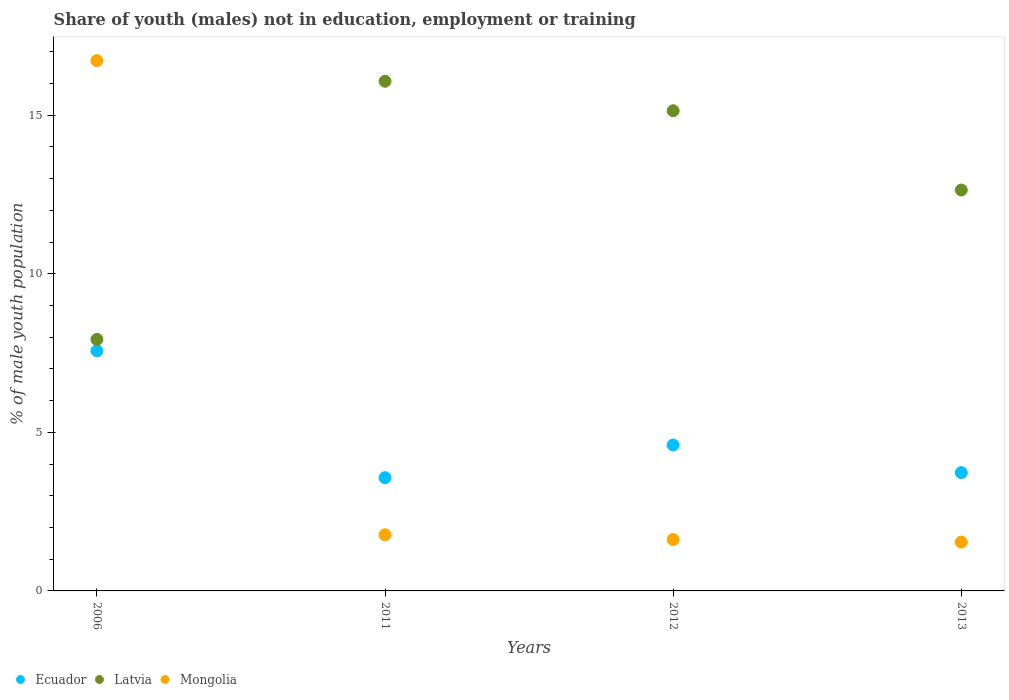Is the number of dotlines equal to the number of legend labels?
Give a very brief answer. Yes. What is the percentage of unemployed males population in in Ecuador in 2006?
Give a very brief answer. 7.57. Across all years, what is the maximum percentage of unemployed males population in in Ecuador?
Give a very brief answer. 7.57. Across all years, what is the minimum percentage of unemployed males population in in Ecuador?
Provide a short and direct response. 3.57. What is the total percentage of unemployed males population in in Ecuador in the graph?
Ensure brevity in your answer.  19.47. What is the difference between the percentage of unemployed males population in in Mongolia in 2011 and that in 2012?
Ensure brevity in your answer.  0.15. What is the difference between the percentage of unemployed males population in in Latvia in 2013 and the percentage of unemployed males population in in Ecuador in 2012?
Provide a short and direct response. 8.04. What is the average percentage of unemployed males population in in Mongolia per year?
Your answer should be very brief. 5.41. In the year 2006, what is the difference between the percentage of unemployed males population in in Mongolia and percentage of unemployed males population in in Ecuador?
Offer a terse response. 9.15. In how many years, is the percentage of unemployed males population in in Ecuador greater than 9 %?
Make the answer very short. 0. What is the ratio of the percentage of unemployed males population in in Mongolia in 2011 to that in 2012?
Keep it short and to the point. 1.09. What is the difference between the highest and the second highest percentage of unemployed males population in in Ecuador?
Provide a short and direct response. 2.97. What is the difference between the highest and the lowest percentage of unemployed males population in in Ecuador?
Keep it short and to the point. 4. Is the sum of the percentage of unemployed males population in in Ecuador in 2011 and 2013 greater than the maximum percentage of unemployed males population in in Latvia across all years?
Make the answer very short. No. Is it the case that in every year, the sum of the percentage of unemployed males population in in Latvia and percentage of unemployed males population in in Ecuador  is greater than the percentage of unemployed males population in in Mongolia?
Offer a terse response. No. Does the percentage of unemployed males population in in Ecuador monotonically increase over the years?
Make the answer very short. No. How many dotlines are there?
Offer a very short reply. 3. Are the values on the major ticks of Y-axis written in scientific E-notation?
Give a very brief answer. No. Does the graph contain any zero values?
Offer a very short reply. No. How many legend labels are there?
Your response must be concise. 3. What is the title of the graph?
Make the answer very short. Share of youth (males) not in education, employment or training. What is the label or title of the Y-axis?
Provide a short and direct response. % of male youth population. What is the % of male youth population of Ecuador in 2006?
Give a very brief answer. 7.57. What is the % of male youth population of Latvia in 2006?
Provide a short and direct response. 7.93. What is the % of male youth population of Mongolia in 2006?
Your answer should be very brief. 16.72. What is the % of male youth population of Ecuador in 2011?
Offer a very short reply. 3.57. What is the % of male youth population in Latvia in 2011?
Keep it short and to the point. 16.07. What is the % of male youth population in Mongolia in 2011?
Give a very brief answer. 1.77. What is the % of male youth population in Ecuador in 2012?
Provide a succinct answer. 4.6. What is the % of male youth population of Latvia in 2012?
Your response must be concise. 15.14. What is the % of male youth population in Mongolia in 2012?
Offer a terse response. 1.62. What is the % of male youth population in Ecuador in 2013?
Make the answer very short. 3.73. What is the % of male youth population in Latvia in 2013?
Make the answer very short. 12.64. What is the % of male youth population of Mongolia in 2013?
Make the answer very short. 1.54. Across all years, what is the maximum % of male youth population in Ecuador?
Make the answer very short. 7.57. Across all years, what is the maximum % of male youth population in Latvia?
Your answer should be very brief. 16.07. Across all years, what is the maximum % of male youth population in Mongolia?
Offer a terse response. 16.72. Across all years, what is the minimum % of male youth population in Ecuador?
Your answer should be compact. 3.57. Across all years, what is the minimum % of male youth population in Latvia?
Offer a very short reply. 7.93. Across all years, what is the minimum % of male youth population of Mongolia?
Provide a succinct answer. 1.54. What is the total % of male youth population of Ecuador in the graph?
Make the answer very short. 19.47. What is the total % of male youth population in Latvia in the graph?
Keep it short and to the point. 51.78. What is the total % of male youth population of Mongolia in the graph?
Provide a succinct answer. 21.65. What is the difference between the % of male youth population in Latvia in 2006 and that in 2011?
Provide a short and direct response. -8.14. What is the difference between the % of male youth population of Mongolia in 2006 and that in 2011?
Your response must be concise. 14.95. What is the difference between the % of male youth population in Ecuador in 2006 and that in 2012?
Offer a terse response. 2.97. What is the difference between the % of male youth population of Latvia in 2006 and that in 2012?
Give a very brief answer. -7.21. What is the difference between the % of male youth population of Mongolia in 2006 and that in 2012?
Provide a succinct answer. 15.1. What is the difference between the % of male youth population in Ecuador in 2006 and that in 2013?
Make the answer very short. 3.84. What is the difference between the % of male youth population of Latvia in 2006 and that in 2013?
Your response must be concise. -4.71. What is the difference between the % of male youth population in Mongolia in 2006 and that in 2013?
Your answer should be compact. 15.18. What is the difference between the % of male youth population in Ecuador in 2011 and that in 2012?
Make the answer very short. -1.03. What is the difference between the % of male youth population in Latvia in 2011 and that in 2012?
Keep it short and to the point. 0.93. What is the difference between the % of male youth population of Ecuador in 2011 and that in 2013?
Your answer should be very brief. -0.16. What is the difference between the % of male youth population in Latvia in 2011 and that in 2013?
Offer a very short reply. 3.43. What is the difference between the % of male youth population in Mongolia in 2011 and that in 2013?
Give a very brief answer. 0.23. What is the difference between the % of male youth population in Ecuador in 2012 and that in 2013?
Keep it short and to the point. 0.87. What is the difference between the % of male youth population of Latvia in 2012 and that in 2013?
Provide a short and direct response. 2.5. What is the difference between the % of male youth population of Ecuador in 2006 and the % of male youth population of Mongolia in 2011?
Give a very brief answer. 5.8. What is the difference between the % of male youth population in Latvia in 2006 and the % of male youth population in Mongolia in 2011?
Your response must be concise. 6.16. What is the difference between the % of male youth population of Ecuador in 2006 and the % of male youth population of Latvia in 2012?
Provide a succinct answer. -7.57. What is the difference between the % of male youth population in Ecuador in 2006 and the % of male youth population in Mongolia in 2012?
Give a very brief answer. 5.95. What is the difference between the % of male youth population in Latvia in 2006 and the % of male youth population in Mongolia in 2012?
Your answer should be compact. 6.31. What is the difference between the % of male youth population in Ecuador in 2006 and the % of male youth population in Latvia in 2013?
Make the answer very short. -5.07. What is the difference between the % of male youth population of Ecuador in 2006 and the % of male youth population of Mongolia in 2013?
Give a very brief answer. 6.03. What is the difference between the % of male youth population of Latvia in 2006 and the % of male youth population of Mongolia in 2013?
Your answer should be compact. 6.39. What is the difference between the % of male youth population of Ecuador in 2011 and the % of male youth population of Latvia in 2012?
Provide a succinct answer. -11.57. What is the difference between the % of male youth population of Ecuador in 2011 and the % of male youth population of Mongolia in 2012?
Provide a succinct answer. 1.95. What is the difference between the % of male youth population in Latvia in 2011 and the % of male youth population in Mongolia in 2012?
Make the answer very short. 14.45. What is the difference between the % of male youth population of Ecuador in 2011 and the % of male youth population of Latvia in 2013?
Provide a short and direct response. -9.07. What is the difference between the % of male youth population of Ecuador in 2011 and the % of male youth population of Mongolia in 2013?
Your answer should be very brief. 2.03. What is the difference between the % of male youth population in Latvia in 2011 and the % of male youth population in Mongolia in 2013?
Provide a short and direct response. 14.53. What is the difference between the % of male youth population in Ecuador in 2012 and the % of male youth population in Latvia in 2013?
Ensure brevity in your answer.  -8.04. What is the difference between the % of male youth population in Ecuador in 2012 and the % of male youth population in Mongolia in 2013?
Provide a short and direct response. 3.06. What is the difference between the % of male youth population in Latvia in 2012 and the % of male youth population in Mongolia in 2013?
Provide a succinct answer. 13.6. What is the average % of male youth population of Ecuador per year?
Provide a short and direct response. 4.87. What is the average % of male youth population in Latvia per year?
Provide a short and direct response. 12.95. What is the average % of male youth population of Mongolia per year?
Ensure brevity in your answer.  5.41. In the year 2006, what is the difference between the % of male youth population in Ecuador and % of male youth population in Latvia?
Your response must be concise. -0.36. In the year 2006, what is the difference between the % of male youth population in Ecuador and % of male youth population in Mongolia?
Your response must be concise. -9.15. In the year 2006, what is the difference between the % of male youth population of Latvia and % of male youth population of Mongolia?
Ensure brevity in your answer.  -8.79. In the year 2011, what is the difference between the % of male youth population in Ecuador and % of male youth population in Latvia?
Offer a very short reply. -12.5. In the year 2011, what is the difference between the % of male youth population in Ecuador and % of male youth population in Mongolia?
Your response must be concise. 1.8. In the year 2011, what is the difference between the % of male youth population in Latvia and % of male youth population in Mongolia?
Ensure brevity in your answer.  14.3. In the year 2012, what is the difference between the % of male youth population of Ecuador and % of male youth population of Latvia?
Provide a short and direct response. -10.54. In the year 2012, what is the difference between the % of male youth population of Ecuador and % of male youth population of Mongolia?
Keep it short and to the point. 2.98. In the year 2012, what is the difference between the % of male youth population in Latvia and % of male youth population in Mongolia?
Your answer should be very brief. 13.52. In the year 2013, what is the difference between the % of male youth population in Ecuador and % of male youth population in Latvia?
Provide a short and direct response. -8.91. In the year 2013, what is the difference between the % of male youth population of Ecuador and % of male youth population of Mongolia?
Your response must be concise. 2.19. In the year 2013, what is the difference between the % of male youth population of Latvia and % of male youth population of Mongolia?
Provide a succinct answer. 11.1. What is the ratio of the % of male youth population of Ecuador in 2006 to that in 2011?
Make the answer very short. 2.12. What is the ratio of the % of male youth population in Latvia in 2006 to that in 2011?
Your answer should be compact. 0.49. What is the ratio of the % of male youth population of Mongolia in 2006 to that in 2011?
Your answer should be compact. 9.45. What is the ratio of the % of male youth population of Ecuador in 2006 to that in 2012?
Ensure brevity in your answer.  1.65. What is the ratio of the % of male youth population in Latvia in 2006 to that in 2012?
Offer a very short reply. 0.52. What is the ratio of the % of male youth population of Mongolia in 2006 to that in 2012?
Offer a terse response. 10.32. What is the ratio of the % of male youth population in Ecuador in 2006 to that in 2013?
Your answer should be compact. 2.03. What is the ratio of the % of male youth population in Latvia in 2006 to that in 2013?
Your answer should be very brief. 0.63. What is the ratio of the % of male youth population in Mongolia in 2006 to that in 2013?
Your response must be concise. 10.86. What is the ratio of the % of male youth population of Ecuador in 2011 to that in 2012?
Provide a succinct answer. 0.78. What is the ratio of the % of male youth population in Latvia in 2011 to that in 2012?
Ensure brevity in your answer.  1.06. What is the ratio of the % of male youth population in Mongolia in 2011 to that in 2012?
Ensure brevity in your answer.  1.09. What is the ratio of the % of male youth population in Ecuador in 2011 to that in 2013?
Give a very brief answer. 0.96. What is the ratio of the % of male youth population of Latvia in 2011 to that in 2013?
Your answer should be compact. 1.27. What is the ratio of the % of male youth population of Mongolia in 2011 to that in 2013?
Offer a terse response. 1.15. What is the ratio of the % of male youth population in Ecuador in 2012 to that in 2013?
Provide a short and direct response. 1.23. What is the ratio of the % of male youth population of Latvia in 2012 to that in 2013?
Your answer should be very brief. 1.2. What is the ratio of the % of male youth population in Mongolia in 2012 to that in 2013?
Your response must be concise. 1.05. What is the difference between the highest and the second highest % of male youth population in Ecuador?
Keep it short and to the point. 2.97. What is the difference between the highest and the second highest % of male youth population of Latvia?
Give a very brief answer. 0.93. What is the difference between the highest and the second highest % of male youth population in Mongolia?
Keep it short and to the point. 14.95. What is the difference between the highest and the lowest % of male youth population of Ecuador?
Offer a terse response. 4. What is the difference between the highest and the lowest % of male youth population of Latvia?
Keep it short and to the point. 8.14. What is the difference between the highest and the lowest % of male youth population of Mongolia?
Provide a succinct answer. 15.18. 